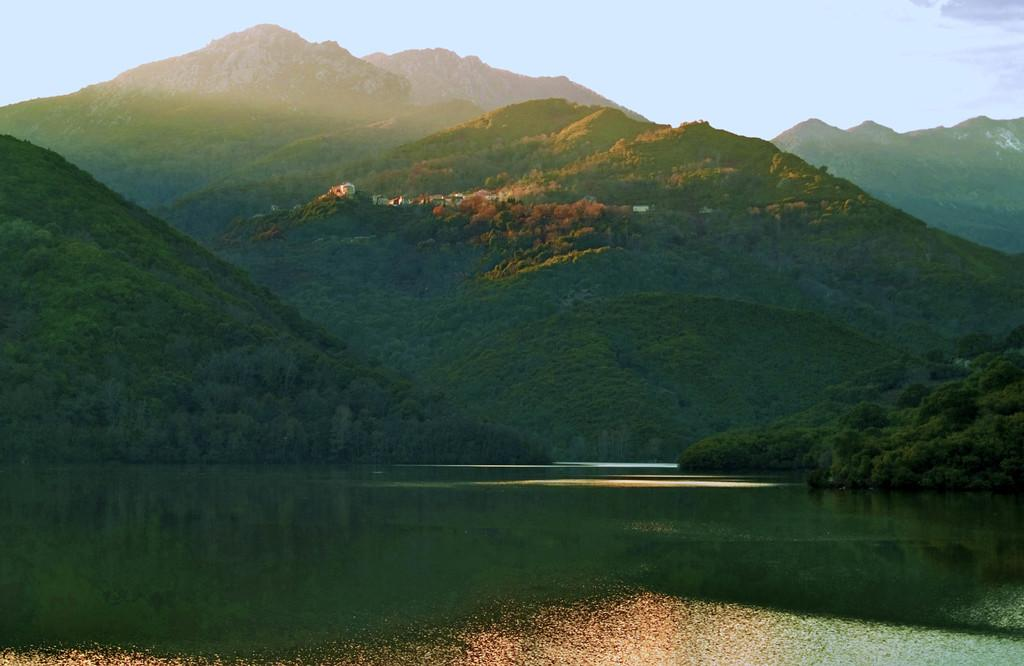What type of natural landform can be seen in the image? There are mountains in the image. What other natural elements are present in the image? There are trees and a lake in the image. Can you describe the location of the lake in relation to the mountains? The lake is between the mountains in the image. What type of ship can be seen sailing through the hall in the image? There is no ship or hall present in the image; it features mountains, trees, and a lake. 